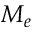<formula> <loc_0><loc_0><loc_500><loc_500>M _ { e }</formula> 